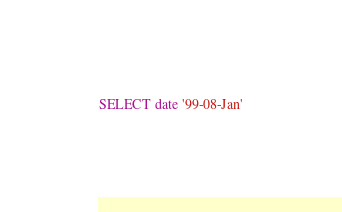Convert code to text. <code><loc_0><loc_0><loc_500><loc_500><_SQL_>SELECT date '99-08-Jan'
</code> 